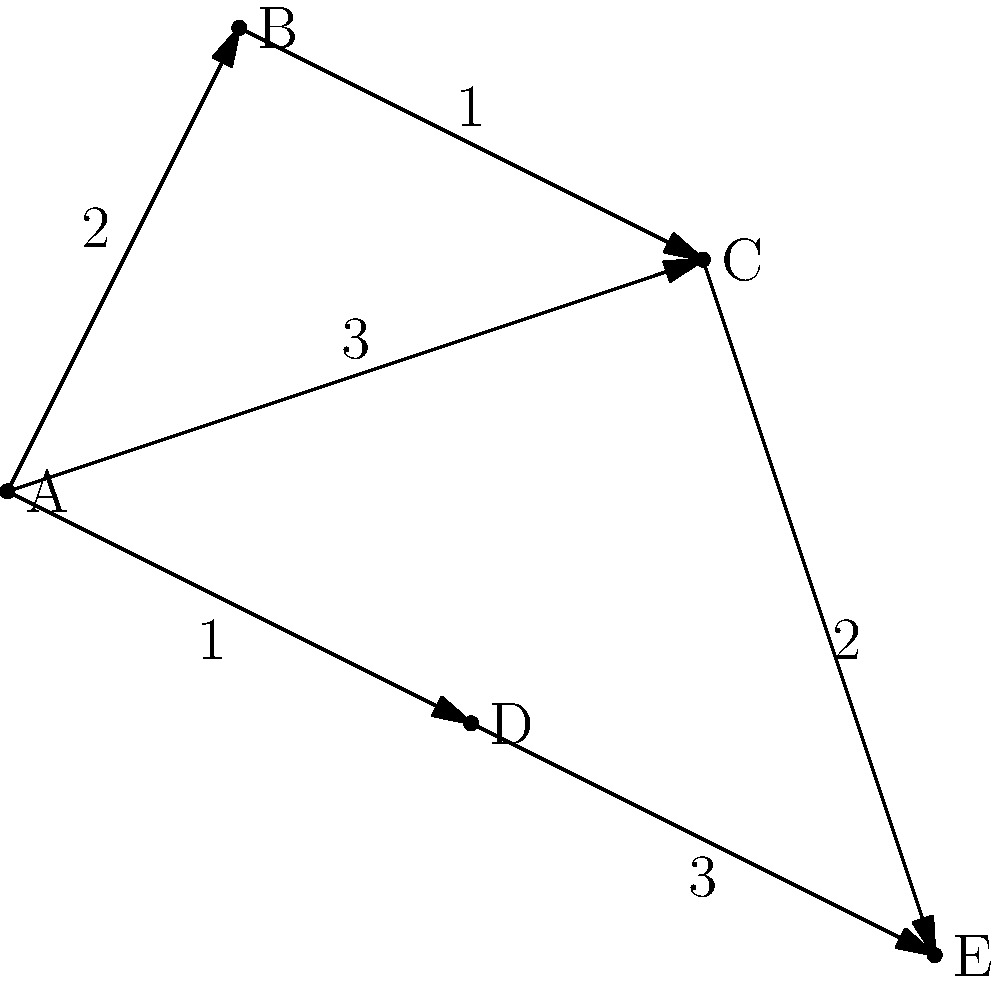As a truck operator, you need to make deliveries to five locations (A, B, C, D, and E) represented as nodes on the graph. The numbers on the edges represent the time (in hours) it takes to travel between locations. What is the minimum time required to visit all locations, starting and ending at location A, if you must visit each location exactly once? To solve this problem, we need to find the shortest Hamiltonian cycle in the graph, also known as the Traveling Salesman Problem. Let's approach this step-by-step:

1. List all possible routes starting and ending at A:
   A-B-C-D-E-A
   A-B-C-E-D-A
   A-C-B-D-E-A
   A-C-E-D-B-A
   A-D-E-C-B-A

2. Calculate the total time for each route:

   A-B-C-D-E-A:
   $2 + 1 + 2 + 3 + 3 = 11$ hours

   A-B-C-E-D-A:
   $2 + 1 + 2 + 3 + 1 = 9$ hours

   A-C-B-D-E-A:
   $3 + 1 + 2 + 3 + 3 = 12$ hours

   A-C-E-D-B-A:
   $3 + 2 + 3 + 1 + 2 = 11$ hours

   A-D-E-C-B-A:
   $1 + 3 + 2 + 1 + 2 = 9$ hours

3. Identify the routes with the minimum time:
   A-B-C-E-D-A and A-D-E-C-B-A both take 9 hours.

Therefore, the minimum time required to visit all locations, starting and ending at A, is 9 hours.
Answer: 9 hours 